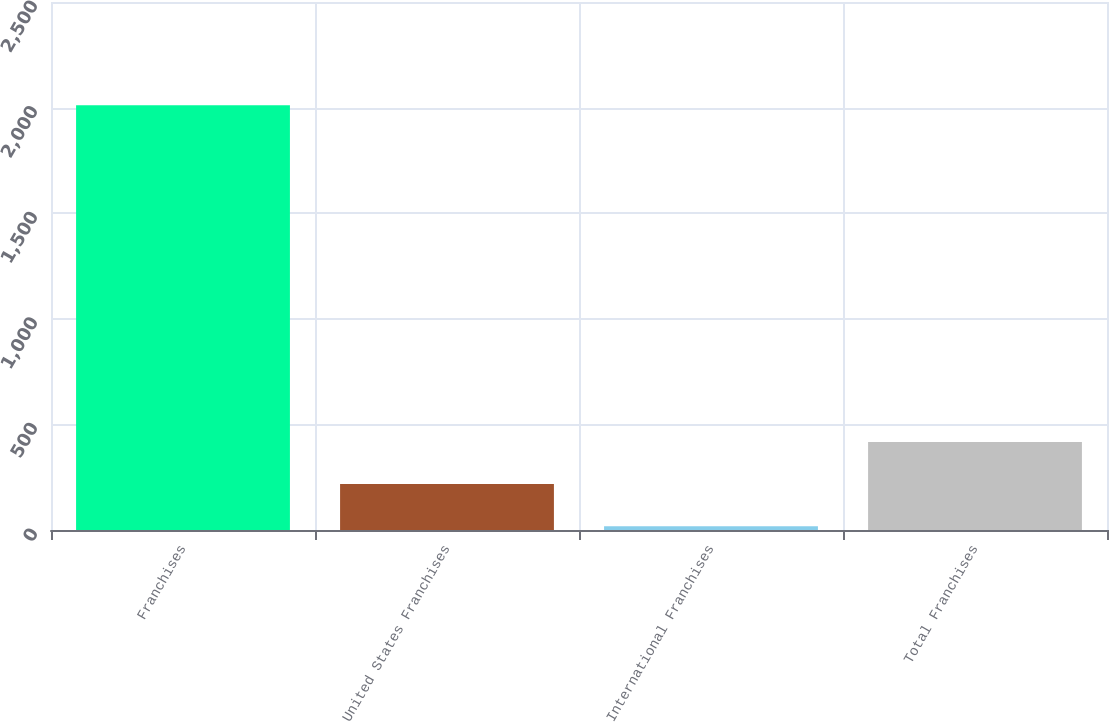Convert chart to OTSL. <chart><loc_0><loc_0><loc_500><loc_500><bar_chart><fcel>Franchises<fcel>United States Franchises<fcel>International Franchises<fcel>Total Franchises<nl><fcel>2011<fcel>217.3<fcel>18<fcel>416.6<nl></chart> 